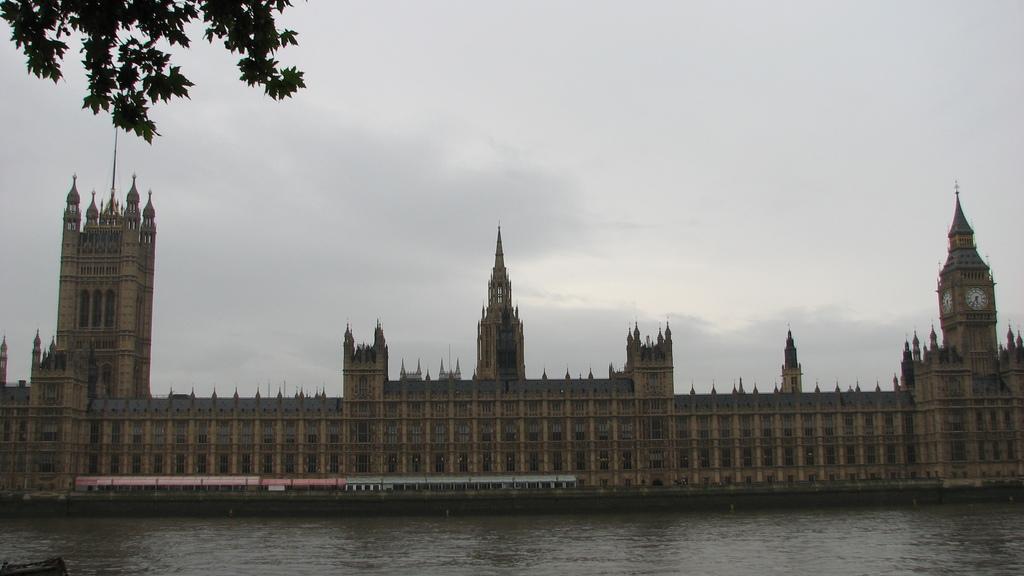Please provide a concise description of this image. This looks like a building with the windows. I think this is a train. This looks like a river with the water flowing. I can see a clock tower with the wall clocks attached to the building wall. Here is the sky. At the top left corner of the image, I can see the branches with the leaves. 